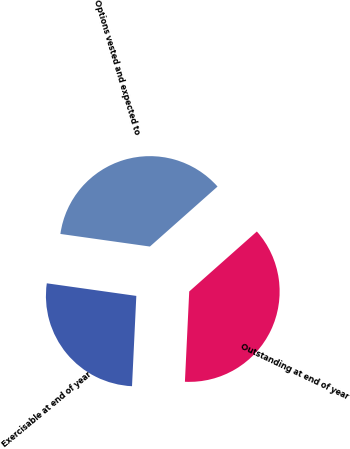Convert chart. <chart><loc_0><loc_0><loc_500><loc_500><pie_chart><fcel>Outstanding at end of year<fcel>Exercisable at end of year<fcel>Options vested and expected to<nl><fcel>37.31%<fcel>26.47%<fcel>36.23%<nl></chart> 